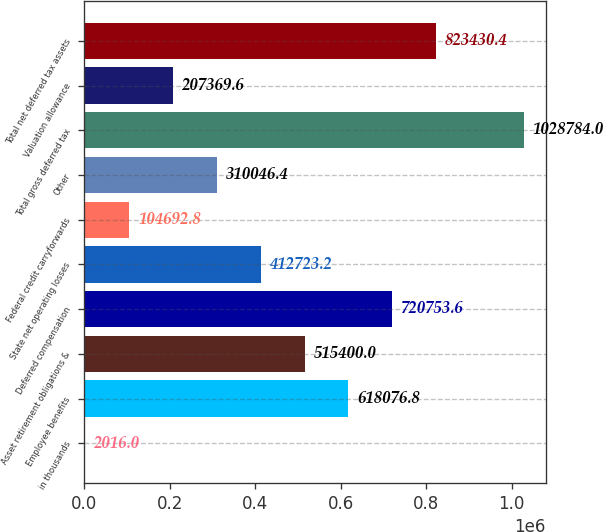Convert chart. <chart><loc_0><loc_0><loc_500><loc_500><bar_chart><fcel>in thousands<fcel>Employee benefits<fcel>Asset retirement obligations &<fcel>Deferred compensation<fcel>State net operating losses<fcel>Federal credit carryforwards<fcel>Other<fcel>Total gross deferred tax<fcel>Valuation allowance<fcel>Total net deferred tax assets<nl><fcel>2016<fcel>618077<fcel>515400<fcel>720754<fcel>412723<fcel>104693<fcel>310046<fcel>1.02878e+06<fcel>207370<fcel>823430<nl></chart> 